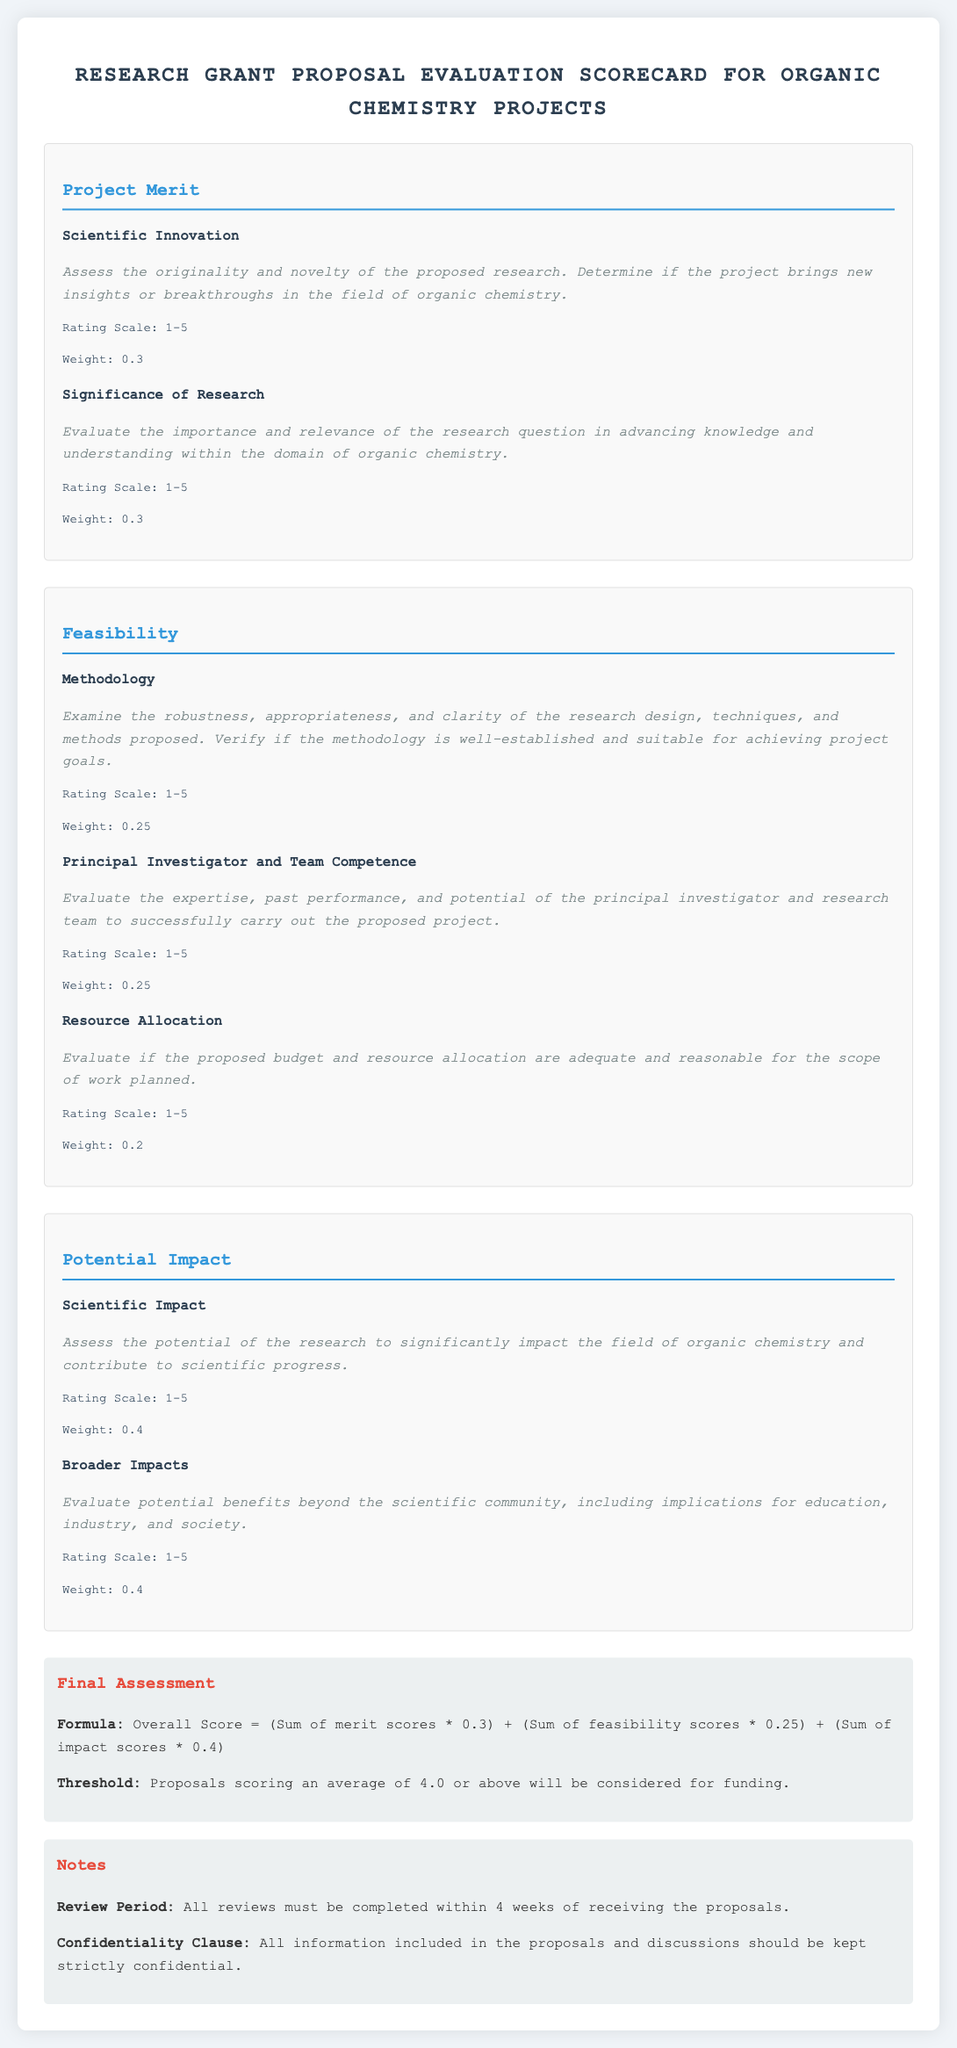What is the title of the document? The title of the document can be found in the header section and reflects its focus on evaluating research grant proposals in organic chemistry.
Answer: Research Grant Proposal Evaluation Scorecard for Organic Chemistry Projects What is the weight of the Scientific Innovation criterion? The weight of the Scientific Innovation criterion is specified in the Project Merit section of the scorecard.
Answer: 0.3 What is the rating scale for the Principal Investigator and Team Competence criterion? The rating scale for this criterion is provided to assess the competence of the research team during evaluation.
Answer: 1-5 What is the threshold score for funding consideration? The threshold score for proposals to be considered for funding is explicitly stated in the Final Assessment section.
Answer: 4.0 How long is the review period for the proposals? The review period duration is clearly mentioned in the Notes section of the document regarding the timeframe for completion.
Answer: 4 weeks Which section evaluates the importance and relevance of the research question? The specific section that focuses on the relevance of the research question in advancing knowledge is included in the Project Merit section.
Answer: Significance of Research What are the two types of impact assessed in the Potential Impact section? This section outlines the specific types of impact that are evaluated when considering the potential benefits of the research.
Answer: Scientific Impact and Broader Impacts What is included in the confidentiality clause? The confidentiality clause specifies how the information from the proposals should be treated, which is detailed in the Notes section.
Answer: Strictly confidential 